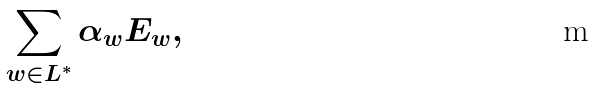Convert formula to latex. <formula><loc_0><loc_0><loc_500><loc_500>\sum _ { w \in L ^ { * } } \alpha _ { w } E _ { w } ,</formula> 